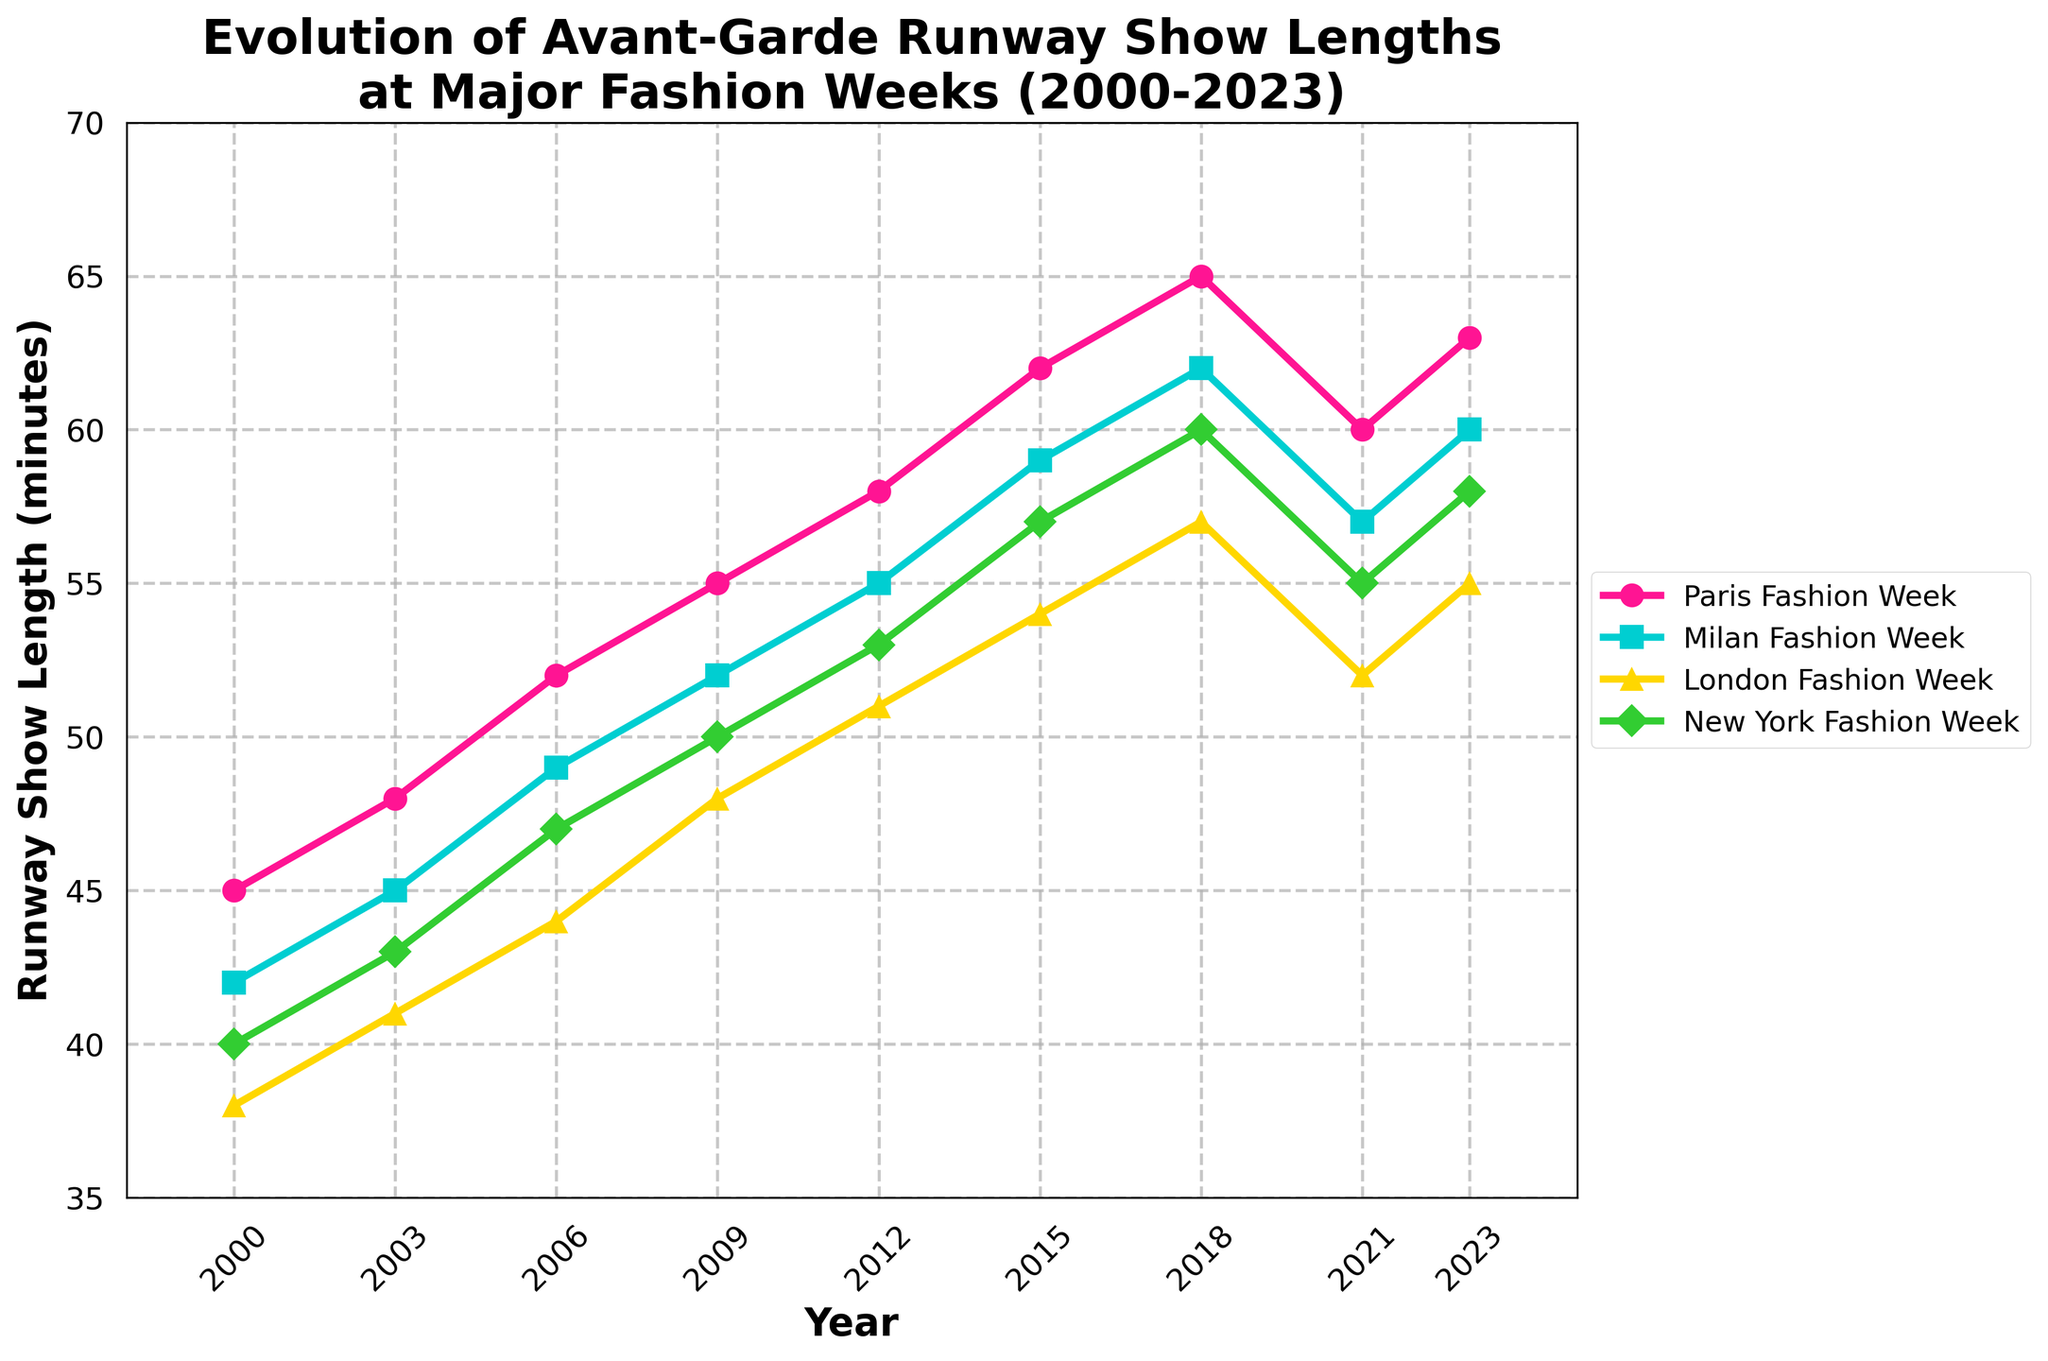How did the length of runway shows at Paris Fashion Week change from 2000 to 2023? Paris Fashion Week showed an increase from 45 minutes in 2000 to 63 minutes in 2023.
Answer: Increased by 18 minutes Which fashion week had the shortest average show length over the period? To find the shortest average, sum and then average each fashion week's show lengths from the data. The average show lengths (Paris, Milan, London, New York) are (55.33, 53.44, 48.88, 51.44) respectively. Thus, London Fashion Week had the shortest average length.
Answer: London Fashion Week Which year had the largest difference in runway show lengths between Paris and Milan Fashion Week? By computing the differences for each year: 2000 (3), 2003 (3), 2006 (3), 2009 (3), 2012 (3), 2015 (3), 2018 (3), 2021 (3), 2023 (3). So, the difference is consistently the same each year.
Answer: Consistently 3 minutes What was the trend in runway show lengths at London Fashion Week between 2009 and 2018? The show length increased from 48 minutes in 2009 to 57 minutes in 2018.
Answer: Increased by 9 minutes Which fashion week had the most significant decrease in show length in 2021? Comparing 2021 lengths with 2018: Paris (5), Milan (5), London (5), New York (5). All had an equal decrease in runway show lengths in 2021.
Answer: All had equal decrease How did the show length trends differ between Paris and Milan Fashion Weeks from 2000 to 2023? Both fashion weeks show a similar trend of increasing runway show lengths over time, with Paris consistently being 3 minutes longer each year.
Answer: Similar, Paris consistently 3 minutes longer What is the difference in the 2023 runway show lengths between the longest and shortest fashion weeks? For 2023, the lengths are: Paris (63), Milan (60), London (55), New York (58). The difference between the longest (Paris) and shortest (London) is 63 - 55 = 8 minutes.
Answer: 8 minutes Considering all the trends, which fashion week consistently had the longest show length from 2000 to 2023? Paris Fashion Week consistently had the longest show lengths each year from 2000 to 2023.
Answer: Paris Fashion Week Between which two consecutive years did New York Fashion Week see the most significant increase in show length? Differences between consecutive years for New York Fashion Week show 2000-2003 (3), 2003-2006 (4), 2006-2009 (3), 2009-2012 (3), 2012-2015 (4), 2015-2018 (3), 2018-2021 (-5), 2021-2023 (3). Thus, the most significant increase was 2003-2006 and 2012-2015.
Answer: 2003-2006 and 2012-2015 (both 4 minutes) By how many minutes did the Milan Fashion Week's show length change from 2006 to 2023? Milan Fashion Week increased from 49 minutes in 2006 to 60 minutes in 2023.
Answer: Increased by 11 minutes 